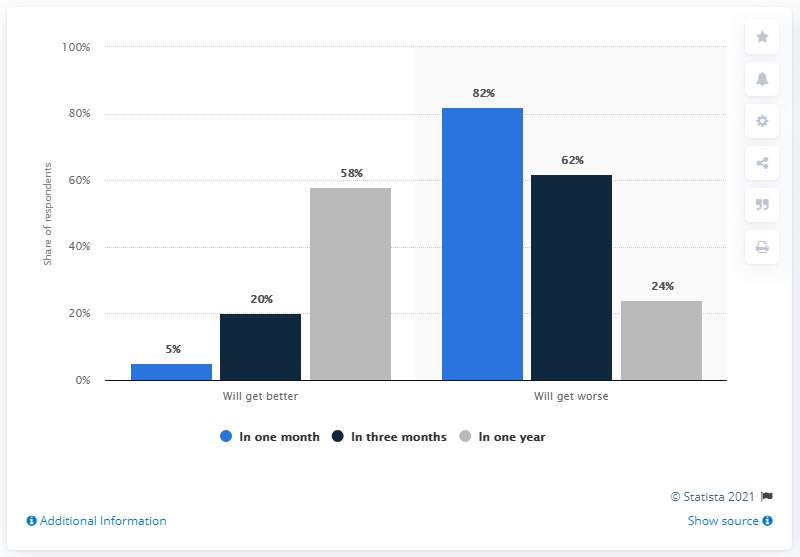Draw attention to some important aspects in this diagram. In the past month, approximately 82% of people who were asked about the future state of a particular issue replied that it would worsen. The ratio between "will get better in one year" and "will get worse in one year" is approximately 2.4167... 